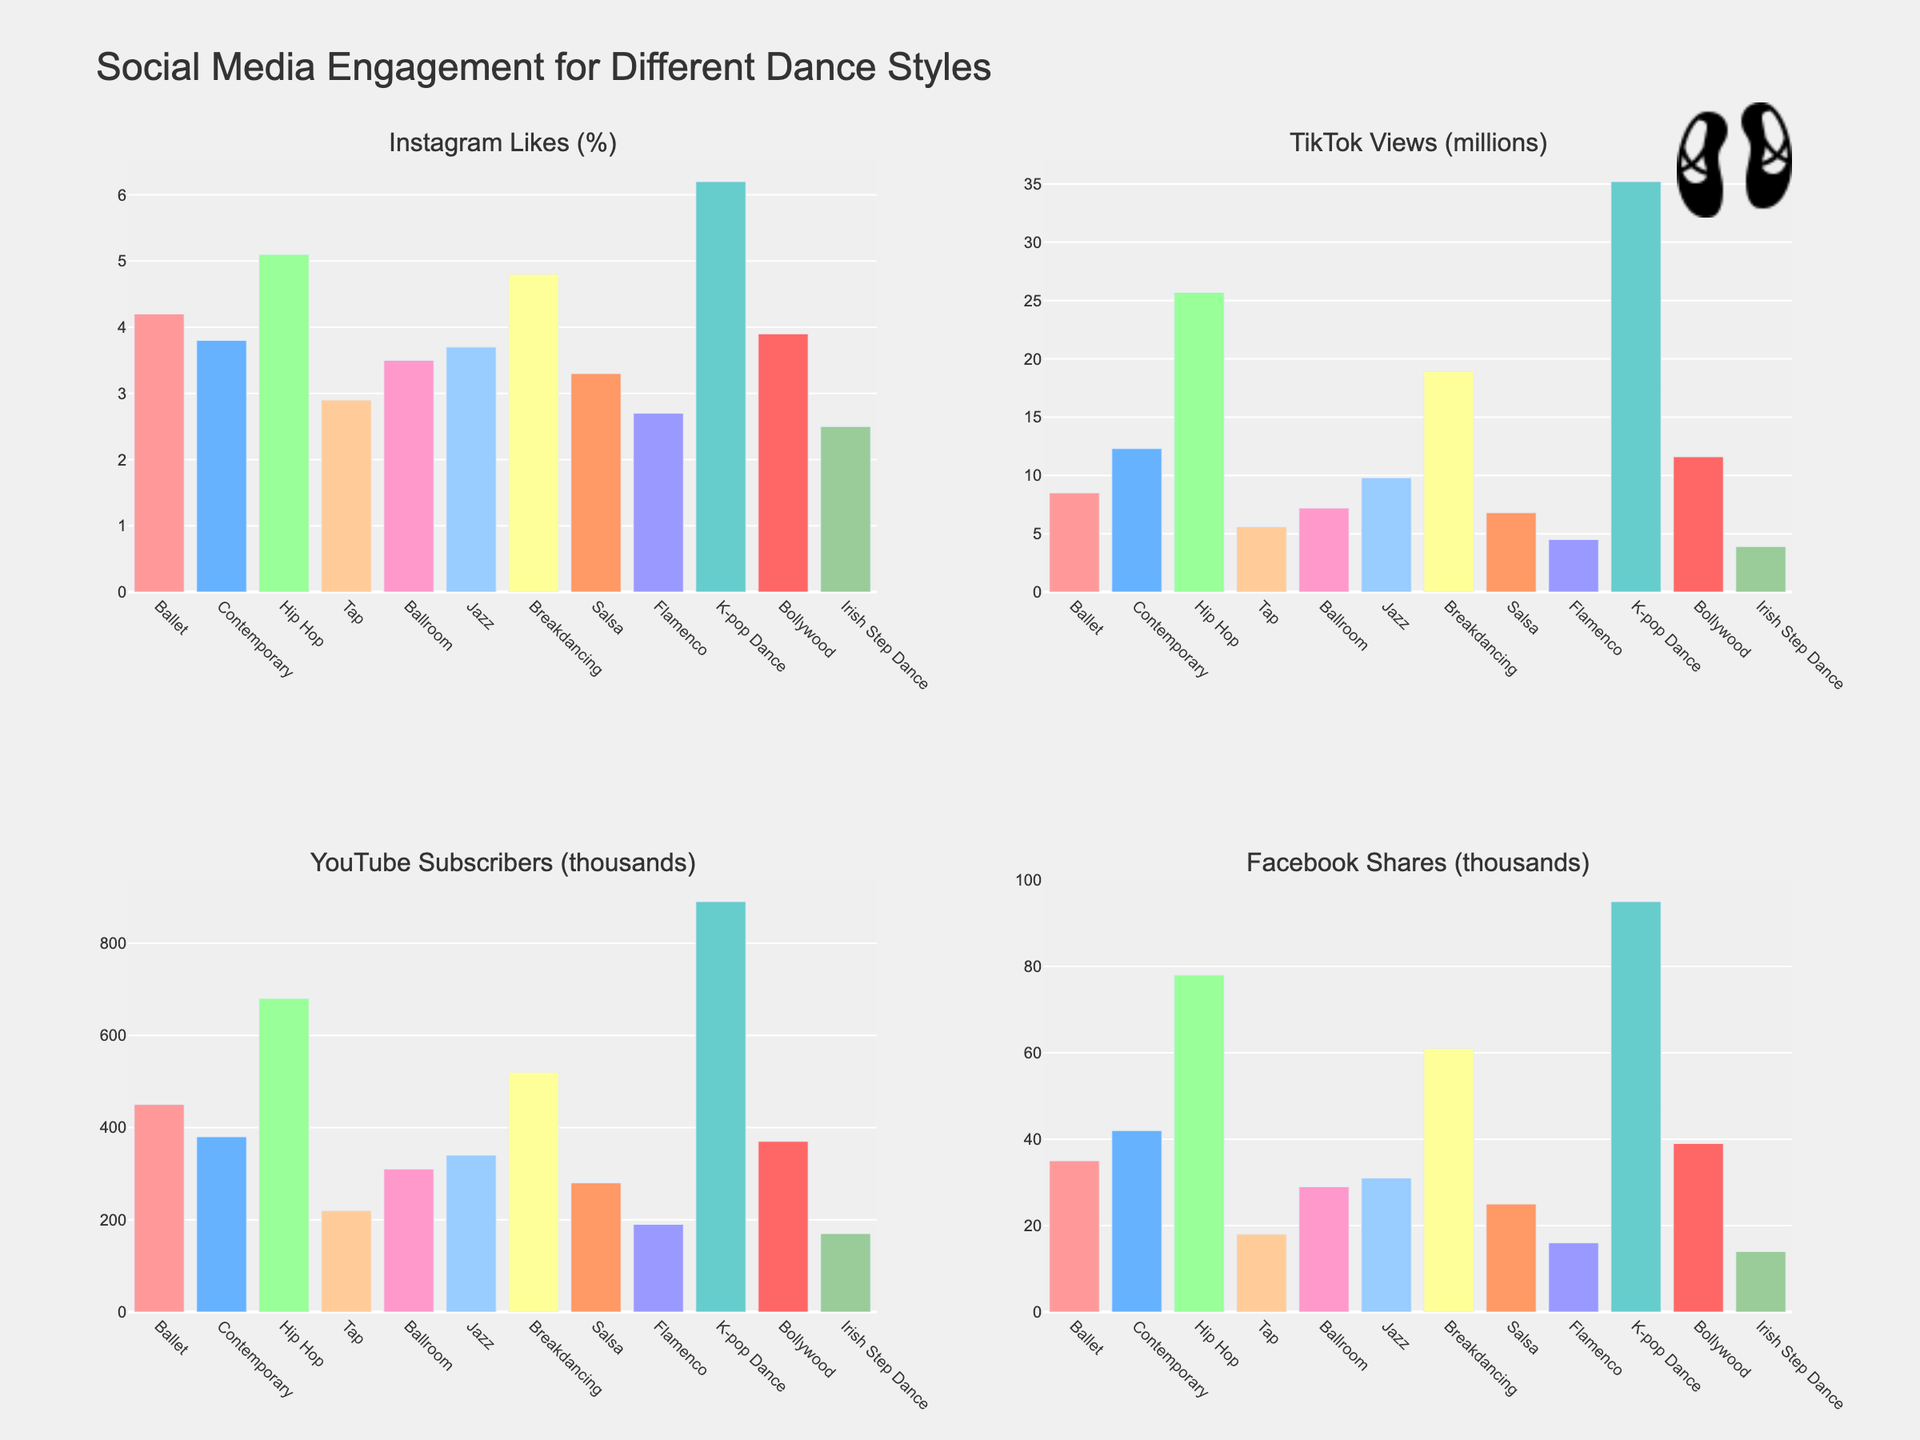What type of dance has the highest percentage of Instagram Likes? Analyze the bar chart for Instagram Likes and identify the tallest bar. The tallest bar corresponds to K-pop Dance.
Answer: K-pop Dance Which type of dance has more TikTok views: Ballet or Salsa? Compare the height of the bars for Ballet and Salsa in the TikTok Views subplot. Salsa has a shorter bar compared to Ballet.
Answer: Ballet How many more YouTube subscribers does Hip Hop have compared to Contemporary? Look at the YouTube Subscribers subplot and find the bars for Hip Hop and Contemporary. Hip Hop has 680 thousand subscribers while Contemporary has 380 thousand. Subtract 380 from 680 to find the difference.
Answer: 300 thousand If you sum the Facebook shares for Breakdancing and Jazz, what is the total? Sum the values of Facebook shares for Breakdancing (61 thousand) and Jazz (31 thousand). 61 + 31 = 92.
Answer: 92 thousand Which three types of dances have the lowest Instagram Likes percentage? Identify the three shortest bars in the Instagram Likes subplot. They correspond to Irish Step Dance (2.5%), Flamenco (2.7%), and Tap (2.9%).
Answer: Irish Step Dance, Flamenco, Tap What’s the difference in TikTok views between the dance style with the most views and the dance style with the least views? Identify the tallest and shortest bars in the TikTok Views subplot. The tallest bar is for K-pop Dance (35.2 million) and the shortest bar is for Irish Step Dance (3.9 million). Subtract 3.9 from 35.2.
Answer: 31.3 million Which two types of dances have equal (or almost equal) YouTube Subscribers? Compare the heights of the bars in the YouTube Subscribers subplot. Ballet and Breakdancing have 450 thousand and 520 thousand subscribers, respectively, which are almost equal compared to other differences.
Answer: Ballet, Breakdancing What is the average percentage of Instagram Likes for Ballroom, Jazz, and Bollywood? Find the Instagram Likes percentages for Ballroom (3.5%), Jazz (3.7%), and Bollywood (3.9%). Calculate their sum (3.5 + 3.7 + 3.9 = 11.1) and then divide by 3 to find the average.
Answer: 3.7% Which type of dance has the highest Facebook Shares and by how much more than Ballet? Identify the tallest bar in the Facebook Shares subplot, which is K-pop Dance (95 thousand). Ballet has 35 thousand Facebook shares. Subtract 35 from 95.
Answer: K-pop Dance, 60 thousand Why might Breakdancing have higher TikTok views but not top Instagram Likes? Observe that Breakdancing has the second-highest bar in the TikTok Views subplot but is not among the tallest in the Instagram Likes subplot. The difference in audience preferences and platform engagement for the dynamic and energetic nature of Breakdancing could explain this discrepancy.
Answer: Different audience engagement preferences 